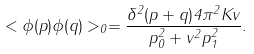Convert formula to latex. <formula><loc_0><loc_0><loc_500><loc_500>< \phi ( p ) \phi ( q ) > _ { 0 } = \frac { \delta ^ { 2 } ( p + q ) 4 \pi ^ { 2 } K v } { p _ { 0 } ^ { 2 } + v ^ { 2 } p _ { 1 } ^ { 2 } } .</formula> 